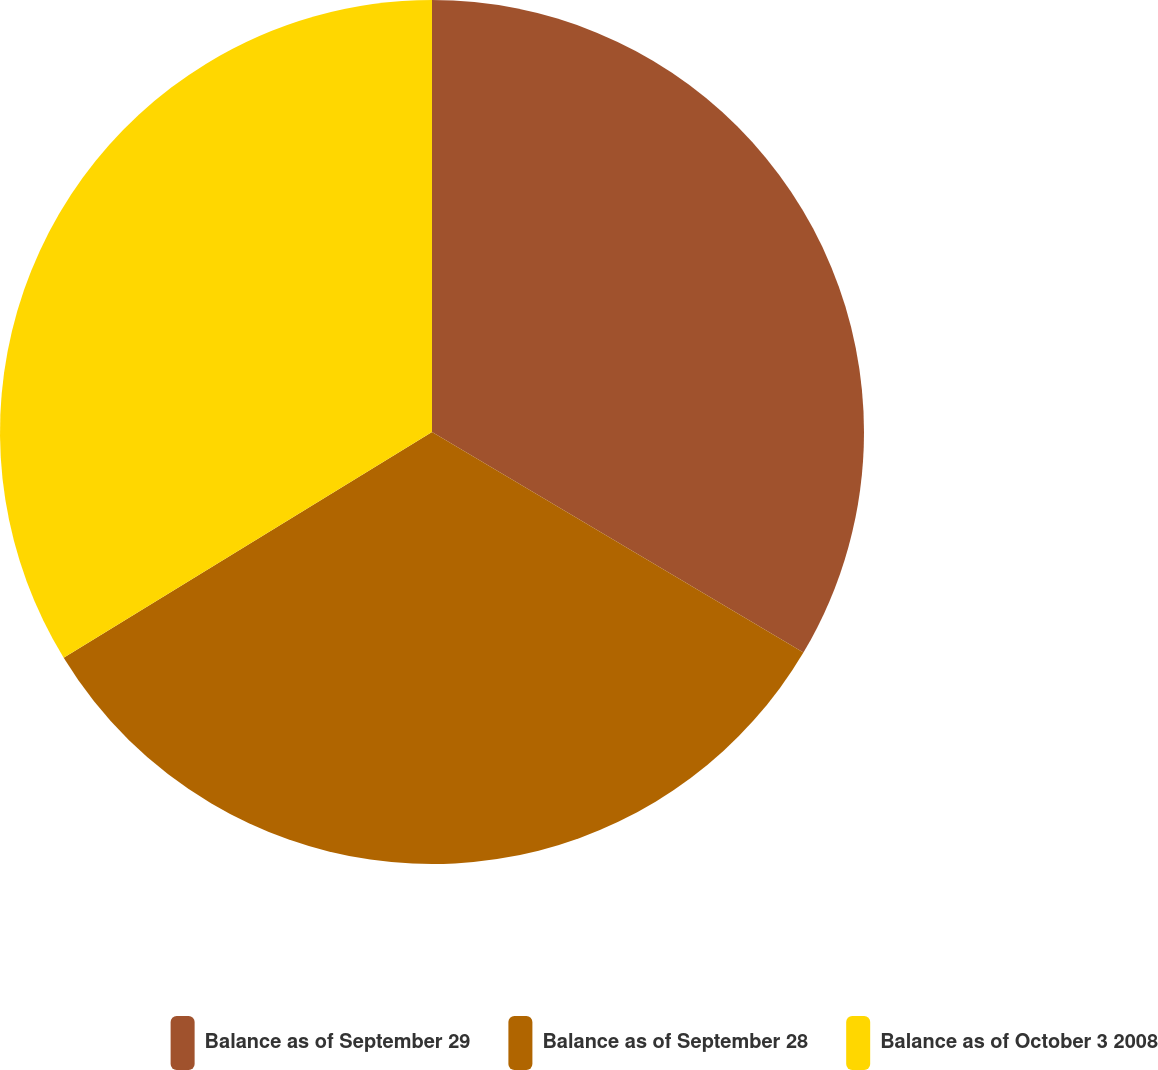Convert chart. <chart><loc_0><loc_0><loc_500><loc_500><pie_chart><fcel>Balance as of September 29<fcel>Balance as of September 28<fcel>Balance as of October 3 2008<nl><fcel>33.53%<fcel>32.72%<fcel>33.75%<nl></chart> 